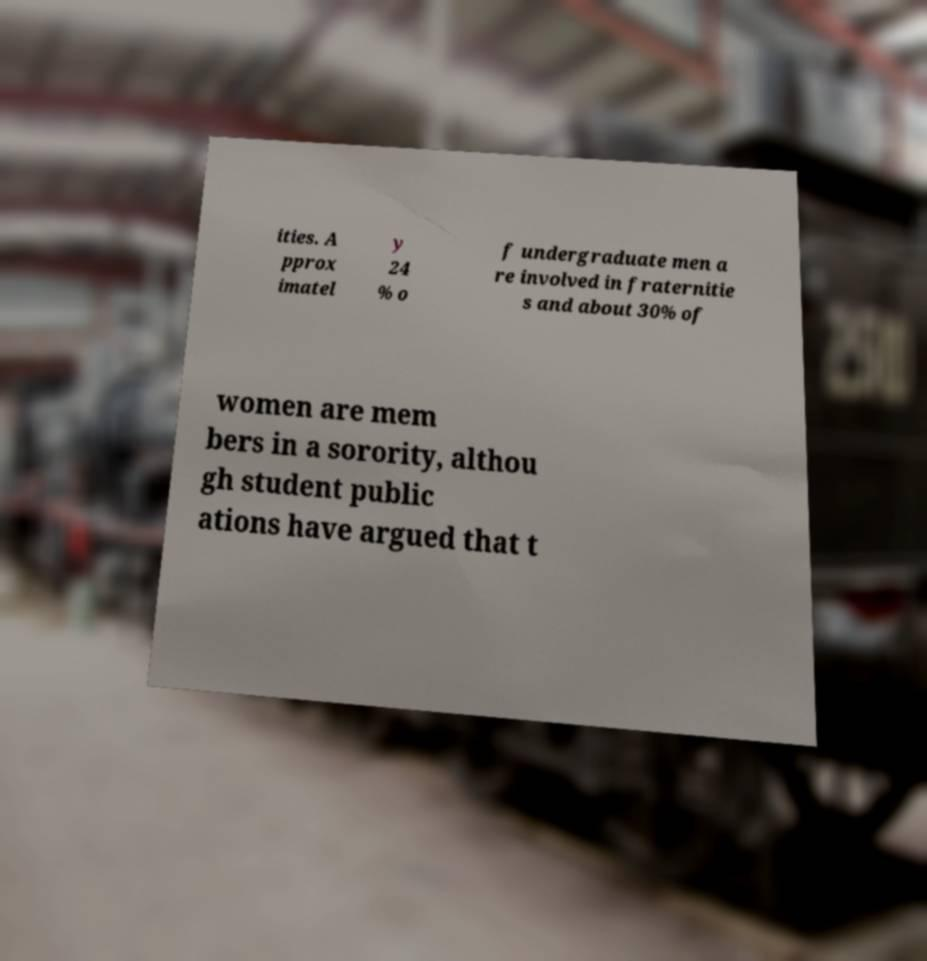There's text embedded in this image that I need extracted. Can you transcribe it verbatim? ities. A pprox imatel y 24 % o f undergraduate men a re involved in fraternitie s and about 30% of women are mem bers in a sorority, althou gh student public ations have argued that t 